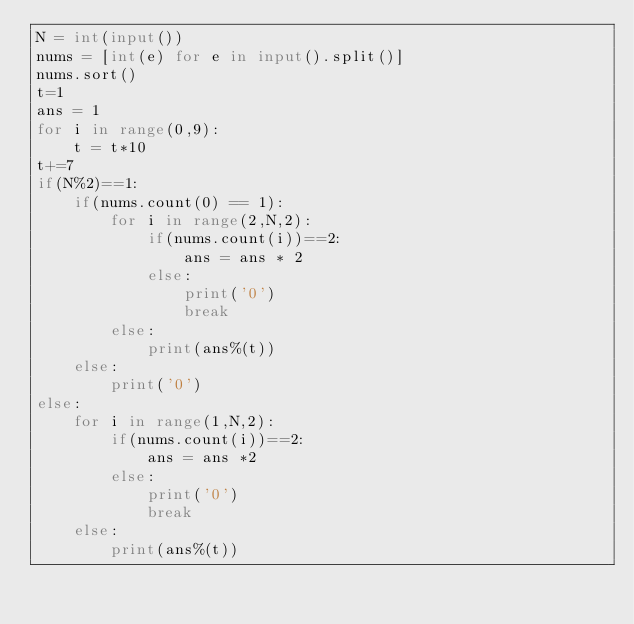<code> <loc_0><loc_0><loc_500><loc_500><_Python_>N = int(input())
nums = [int(e) for e in input().split()]
nums.sort()
t=1
ans = 1
for i in range(0,9):
    t = t*10
t+=7
if(N%2)==1:
    if(nums.count(0) == 1):
        for i in range(2,N,2):
            if(nums.count(i))==2:
                ans = ans * 2
            else:
                print('0')
                break
        else:
            print(ans%(t))
    else:
        print('0')
else:
    for i in range(1,N,2):
        if(nums.count(i))==2:
            ans = ans *2
        else:
            print('0')
            break
    else:
        print(ans%(t))</code> 